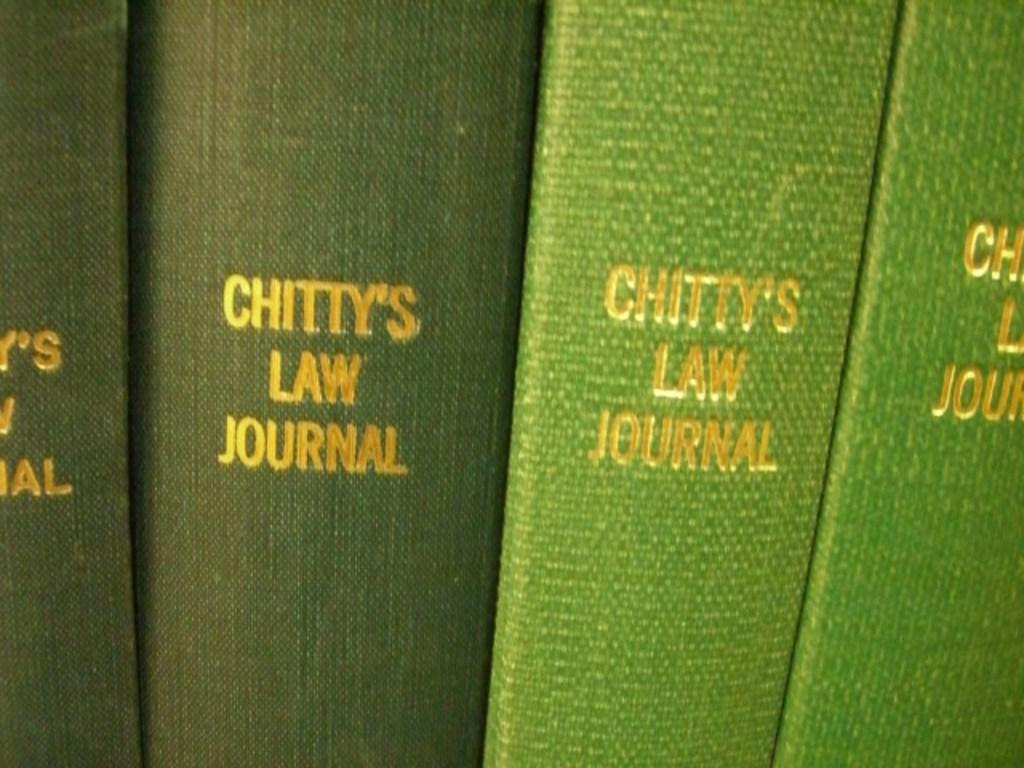What type of note is the woman holding in the image? There is no woman or note present in the image, as the provided facts do not give any clear and specific details about the objects. 